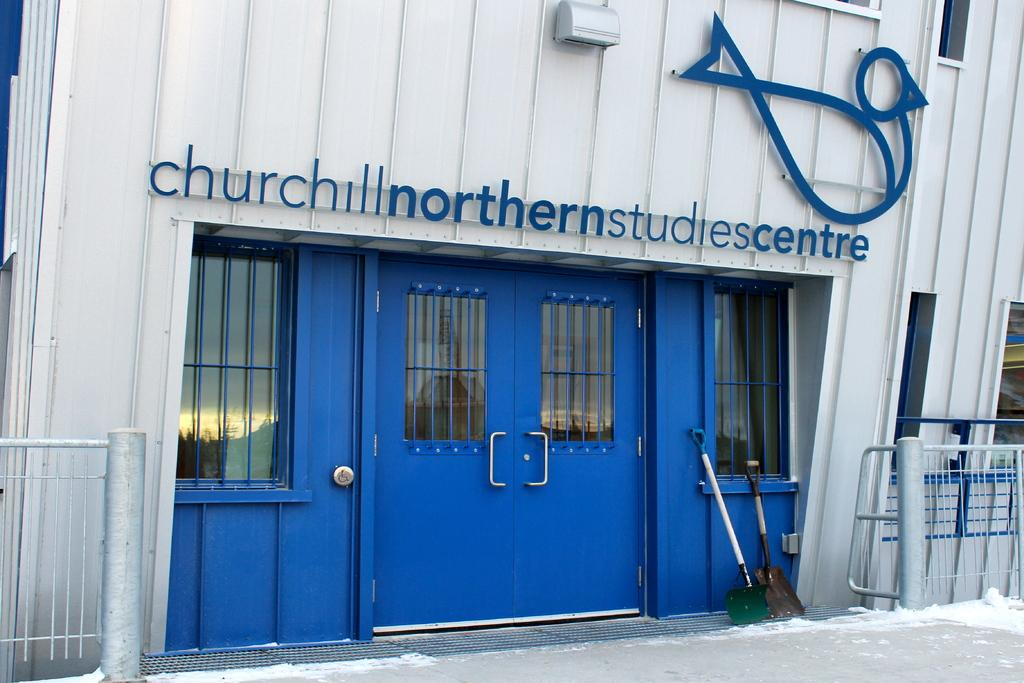<image>
Describe the image concisely. The building behind the blue door is a studies centre. 